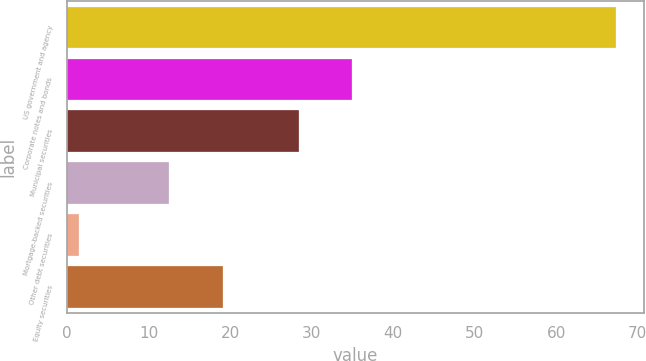Convert chart. <chart><loc_0><loc_0><loc_500><loc_500><bar_chart><fcel>US government and agency<fcel>Corporate notes and bonds<fcel>Municipal securities<fcel>Mortgage-backed securities<fcel>Other debt securities<fcel>Equity securities<nl><fcel>67.4<fcel>34.99<fcel>28.4<fcel>12.5<fcel>1.5<fcel>19.09<nl></chart> 